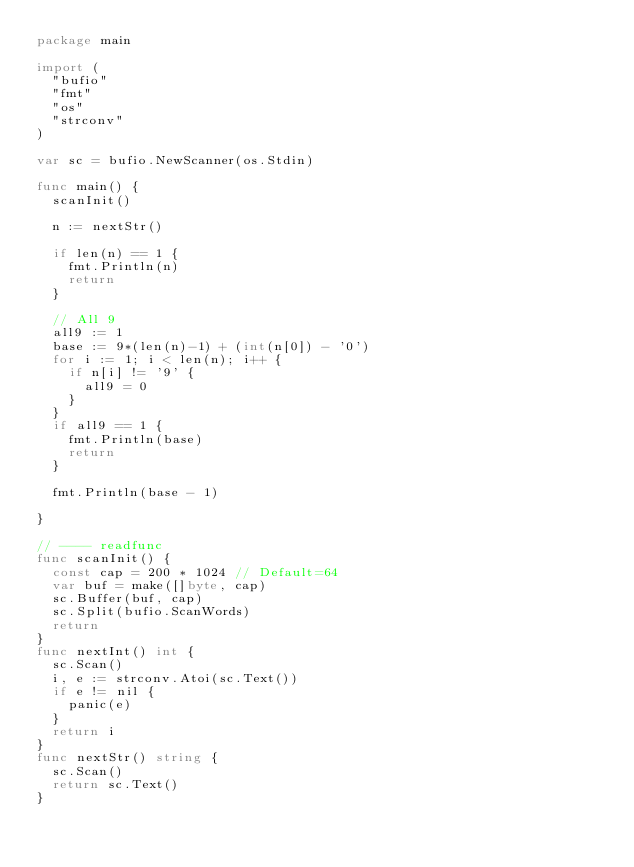Convert code to text. <code><loc_0><loc_0><loc_500><loc_500><_Go_>package main

import (
	"bufio"
	"fmt"
	"os"
	"strconv"
)

var sc = bufio.NewScanner(os.Stdin)

func main() {
	scanInit()

	n := nextStr()

	if len(n) == 1 {
		fmt.Println(n)
		return
	}

	// All 9
	all9 := 1
	base := 9*(len(n)-1) + (int(n[0]) - '0')
	for i := 1; i < len(n); i++ {
		if n[i] != '9' {
			all9 = 0
		}
	}
	if all9 == 1 {
		fmt.Println(base)
		return
	}

	fmt.Println(base - 1)

}

// ---- readfunc
func scanInit() {
	const cap = 200 * 1024 // Default=64
	var buf = make([]byte, cap)
	sc.Buffer(buf, cap)
	sc.Split(bufio.ScanWords)
	return
}
func nextInt() int {
	sc.Scan()
	i, e := strconv.Atoi(sc.Text())
	if e != nil {
		panic(e)
	}
	return i
}
func nextStr() string {
	sc.Scan()
	return sc.Text()
}
</code> 